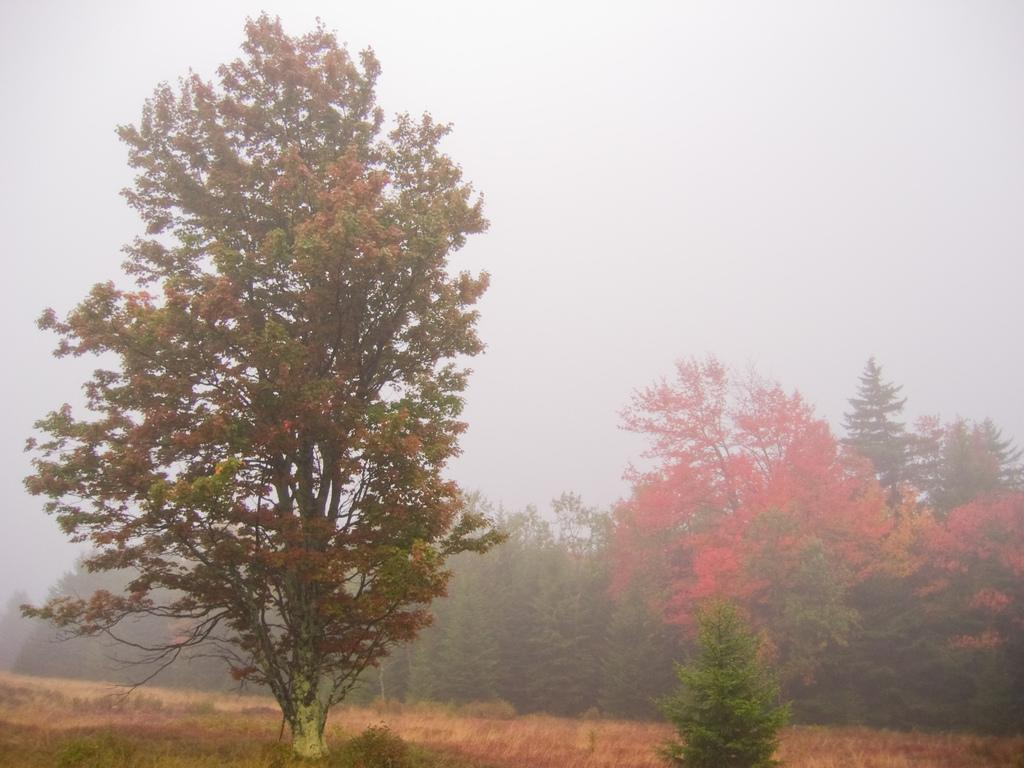What type of vegetation can be seen in the image? There are trees in the image. What color are the flowers on the trees? The flowers on the trees are orange. What is visible at the top of the image? The sky is visible at the top of the image. What type of ground cover is visible at the bottom of the image? There is grass visible at the bottom of the image. Can you see any airplanes taking off or landing at the nearby airport in the image? There is no airport or airplanes visible in the image. What type of knife is being used to cut the branches of the trees in the image? There is no knife or tree-cutting activity depicted in the image. 